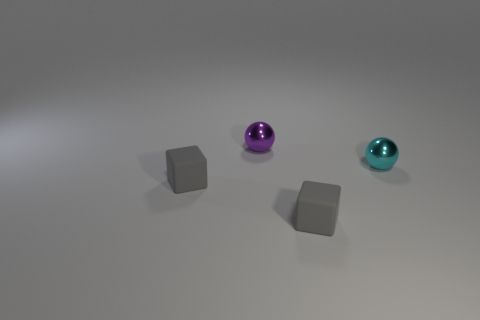Does the metal thing that is left of the tiny cyan metallic ball have the same shape as the tiny cyan thing?
Make the answer very short. Yes. What number of small things are either cyan objects or spheres?
Offer a very short reply. 2. Is the number of small cyan metal things behind the small purple thing the same as the number of small purple shiny balls that are left of the cyan ball?
Ensure brevity in your answer.  No. How many cyan objects are either small matte blocks or metal things?
Offer a terse response. 1. Are there an equal number of tiny gray matte things that are right of the purple thing and purple shiny objects?
Keep it short and to the point. Yes. What color is the other object that is the same shape as the tiny cyan metallic object?
Make the answer very short. Purple. How many small purple metal objects are the same shape as the cyan object?
Your answer should be compact. 1. How many tiny metallic objects are there?
Give a very brief answer. 2. Is there a yellow cylinder made of the same material as the cyan object?
Keep it short and to the point. No. There is a metal thing behind the cyan thing; is it the same size as the cyan metallic sphere that is in front of the purple object?
Provide a short and direct response. Yes. 